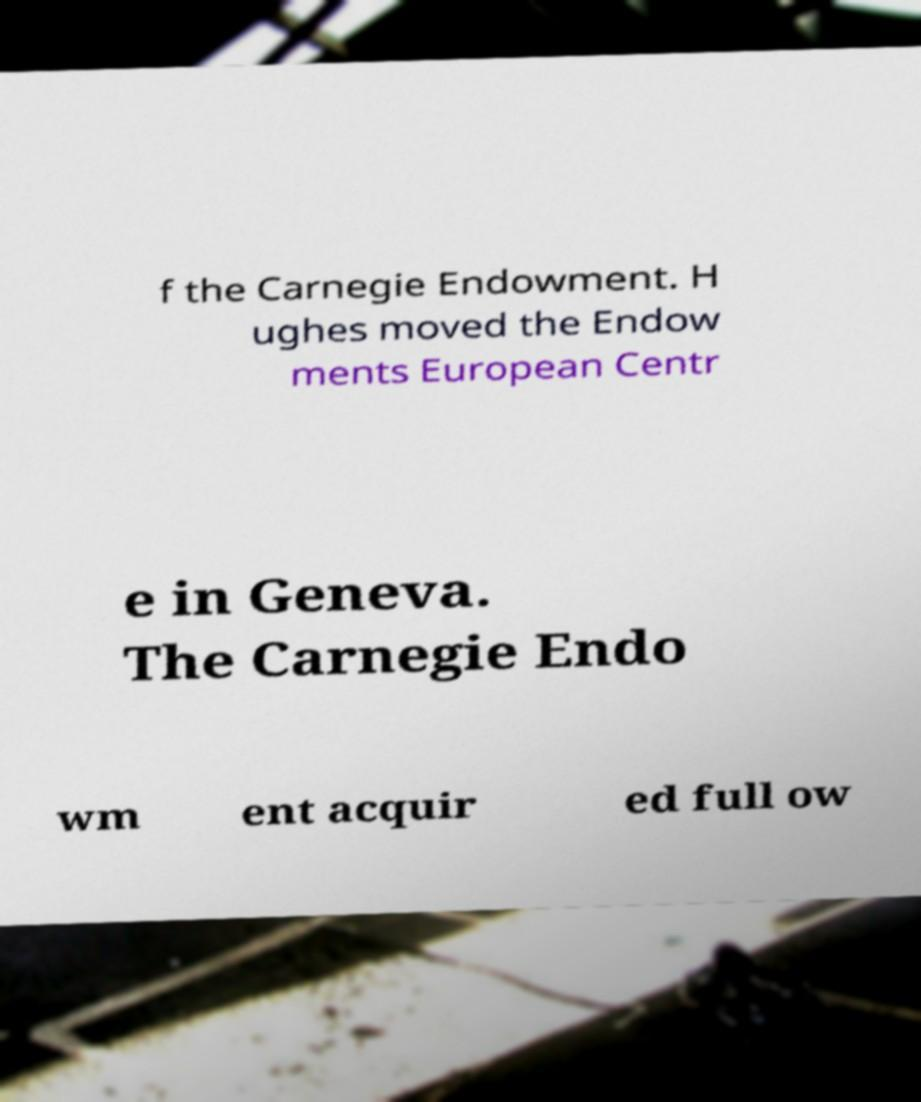For documentation purposes, I need the text within this image transcribed. Could you provide that? f the Carnegie Endowment. H ughes moved the Endow ments European Centr e in Geneva. The Carnegie Endo wm ent acquir ed full ow 